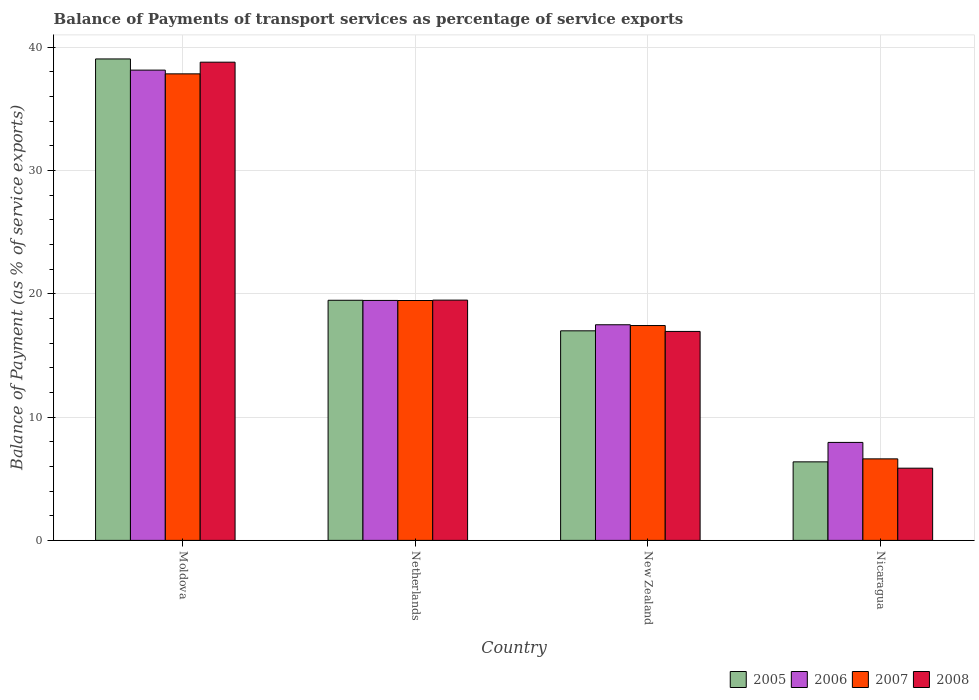How many different coloured bars are there?
Give a very brief answer. 4. Are the number of bars per tick equal to the number of legend labels?
Your response must be concise. Yes. Are the number of bars on each tick of the X-axis equal?
Provide a succinct answer. Yes. How many bars are there on the 2nd tick from the left?
Give a very brief answer. 4. What is the label of the 1st group of bars from the left?
Keep it short and to the point. Moldova. In how many cases, is the number of bars for a given country not equal to the number of legend labels?
Offer a very short reply. 0. What is the balance of payments of transport services in 2006 in Netherlands?
Offer a terse response. 19.46. Across all countries, what is the maximum balance of payments of transport services in 2008?
Your answer should be compact. 38.78. Across all countries, what is the minimum balance of payments of transport services in 2007?
Give a very brief answer. 6.61. In which country was the balance of payments of transport services in 2008 maximum?
Ensure brevity in your answer.  Moldova. In which country was the balance of payments of transport services in 2005 minimum?
Make the answer very short. Nicaragua. What is the total balance of payments of transport services in 2005 in the graph?
Offer a very short reply. 81.87. What is the difference between the balance of payments of transport services in 2006 in Netherlands and that in Nicaragua?
Offer a terse response. 11.51. What is the difference between the balance of payments of transport services in 2006 in New Zealand and the balance of payments of transport services in 2008 in Nicaragua?
Ensure brevity in your answer.  11.63. What is the average balance of payments of transport services in 2007 per country?
Your answer should be compact. 20.33. What is the difference between the balance of payments of transport services of/in 2007 and balance of payments of transport services of/in 2005 in Netherlands?
Give a very brief answer. -0.02. What is the ratio of the balance of payments of transport services in 2007 in New Zealand to that in Nicaragua?
Offer a terse response. 2.64. Is the difference between the balance of payments of transport services in 2007 in Moldova and Nicaragua greater than the difference between the balance of payments of transport services in 2005 in Moldova and Nicaragua?
Your response must be concise. No. What is the difference between the highest and the second highest balance of payments of transport services in 2007?
Offer a very short reply. -2.03. What is the difference between the highest and the lowest balance of payments of transport services in 2005?
Ensure brevity in your answer.  32.67. Is the sum of the balance of payments of transport services in 2008 in Netherlands and Nicaragua greater than the maximum balance of payments of transport services in 2007 across all countries?
Your answer should be very brief. No. What does the 3rd bar from the left in Nicaragua represents?
Offer a terse response. 2007. How many bars are there?
Keep it short and to the point. 16. How many countries are there in the graph?
Offer a terse response. 4. Are the values on the major ticks of Y-axis written in scientific E-notation?
Give a very brief answer. No. Does the graph contain grids?
Ensure brevity in your answer.  Yes. How many legend labels are there?
Your answer should be compact. 4. How are the legend labels stacked?
Ensure brevity in your answer.  Horizontal. What is the title of the graph?
Provide a succinct answer. Balance of Payments of transport services as percentage of service exports. Does "2014" appear as one of the legend labels in the graph?
Your answer should be compact. No. What is the label or title of the X-axis?
Your answer should be very brief. Country. What is the label or title of the Y-axis?
Keep it short and to the point. Balance of Payment (as % of service exports). What is the Balance of Payment (as % of service exports) in 2005 in Moldova?
Your answer should be compact. 39.04. What is the Balance of Payment (as % of service exports) in 2006 in Moldova?
Provide a short and direct response. 38.13. What is the Balance of Payment (as % of service exports) in 2007 in Moldova?
Ensure brevity in your answer.  37.83. What is the Balance of Payment (as % of service exports) of 2008 in Moldova?
Give a very brief answer. 38.78. What is the Balance of Payment (as % of service exports) of 2005 in Netherlands?
Provide a short and direct response. 19.47. What is the Balance of Payment (as % of service exports) in 2006 in Netherlands?
Provide a short and direct response. 19.46. What is the Balance of Payment (as % of service exports) of 2007 in Netherlands?
Make the answer very short. 19.45. What is the Balance of Payment (as % of service exports) in 2008 in Netherlands?
Provide a succinct answer. 19.48. What is the Balance of Payment (as % of service exports) in 2005 in New Zealand?
Make the answer very short. 16.99. What is the Balance of Payment (as % of service exports) in 2006 in New Zealand?
Provide a short and direct response. 17.48. What is the Balance of Payment (as % of service exports) in 2007 in New Zealand?
Your answer should be compact. 17.42. What is the Balance of Payment (as % of service exports) of 2008 in New Zealand?
Your answer should be compact. 16.94. What is the Balance of Payment (as % of service exports) of 2005 in Nicaragua?
Keep it short and to the point. 6.37. What is the Balance of Payment (as % of service exports) in 2006 in Nicaragua?
Your response must be concise. 7.95. What is the Balance of Payment (as % of service exports) in 2007 in Nicaragua?
Ensure brevity in your answer.  6.61. What is the Balance of Payment (as % of service exports) in 2008 in Nicaragua?
Provide a short and direct response. 5.85. Across all countries, what is the maximum Balance of Payment (as % of service exports) in 2005?
Keep it short and to the point. 39.04. Across all countries, what is the maximum Balance of Payment (as % of service exports) of 2006?
Your response must be concise. 38.13. Across all countries, what is the maximum Balance of Payment (as % of service exports) of 2007?
Your answer should be compact. 37.83. Across all countries, what is the maximum Balance of Payment (as % of service exports) in 2008?
Provide a succinct answer. 38.78. Across all countries, what is the minimum Balance of Payment (as % of service exports) in 2005?
Offer a terse response. 6.37. Across all countries, what is the minimum Balance of Payment (as % of service exports) in 2006?
Give a very brief answer. 7.95. Across all countries, what is the minimum Balance of Payment (as % of service exports) in 2007?
Offer a terse response. 6.61. Across all countries, what is the minimum Balance of Payment (as % of service exports) in 2008?
Your answer should be compact. 5.85. What is the total Balance of Payment (as % of service exports) in 2005 in the graph?
Your answer should be compact. 81.87. What is the total Balance of Payment (as % of service exports) of 2006 in the graph?
Ensure brevity in your answer.  83.02. What is the total Balance of Payment (as % of service exports) of 2007 in the graph?
Your answer should be compact. 81.31. What is the total Balance of Payment (as % of service exports) of 2008 in the graph?
Ensure brevity in your answer.  81.06. What is the difference between the Balance of Payment (as % of service exports) of 2005 in Moldova and that in Netherlands?
Provide a succinct answer. 19.57. What is the difference between the Balance of Payment (as % of service exports) of 2006 in Moldova and that in Netherlands?
Provide a short and direct response. 18.67. What is the difference between the Balance of Payment (as % of service exports) of 2007 in Moldova and that in Netherlands?
Give a very brief answer. 18.38. What is the difference between the Balance of Payment (as % of service exports) of 2008 in Moldova and that in Netherlands?
Your answer should be very brief. 19.29. What is the difference between the Balance of Payment (as % of service exports) in 2005 in Moldova and that in New Zealand?
Your answer should be very brief. 22.05. What is the difference between the Balance of Payment (as % of service exports) in 2006 in Moldova and that in New Zealand?
Offer a terse response. 20.65. What is the difference between the Balance of Payment (as % of service exports) of 2007 in Moldova and that in New Zealand?
Keep it short and to the point. 20.41. What is the difference between the Balance of Payment (as % of service exports) of 2008 in Moldova and that in New Zealand?
Provide a succinct answer. 21.83. What is the difference between the Balance of Payment (as % of service exports) in 2005 in Moldova and that in Nicaragua?
Offer a very short reply. 32.67. What is the difference between the Balance of Payment (as % of service exports) in 2006 in Moldova and that in Nicaragua?
Offer a very short reply. 30.19. What is the difference between the Balance of Payment (as % of service exports) in 2007 in Moldova and that in Nicaragua?
Your response must be concise. 31.22. What is the difference between the Balance of Payment (as % of service exports) in 2008 in Moldova and that in Nicaragua?
Offer a very short reply. 32.92. What is the difference between the Balance of Payment (as % of service exports) in 2005 in Netherlands and that in New Zealand?
Ensure brevity in your answer.  2.48. What is the difference between the Balance of Payment (as % of service exports) in 2006 in Netherlands and that in New Zealand?
Your response must be concise. 1.97. What is the difference between the Balance of Payment (as % of service exports) of 2007 in Netherlands and that in New Zealand?
Your answer should be very brief. 2.03. What is the difference between the Balance of Payment (as % of service exports) in 2008 in Netherlands and that in New Zealand?
Make the answer very short. 2.54. What is the difference between the Balance of Payment (as % of service exports) of 2005 in Netherlands and that in Nicaragua?
Provide a succinct answer. 13.1. What is the difference between the Balance of Payment (as % of service exports) of 2006 in Netherlands and that in Nicaragua?
Make the answer very short. 11.51. What is the difference between the Balance of Payment (as % of service exports) of 2007 in Netherlands and that in Nicaragua?
Offer a very short reply. 12.84. What is the difference between the Balance of Payment (as % of service exports) of 2008 in Netherlands and that in Nicaragua?
Offer a very short reply. 13.63. What is the difference between the Balance of Payment (as % of service exports) of 2005 in New Zealand and that in Nicaragua?
Offer a terse response. 10.62. What is the difference between the Balance of Payment (as % of service exports) in 2006 in New Zealand and that in Nicaragua?
Provide a short and direct response. 9.54. What is the difference between the Balance of Payment (as % of service exports) in 2007 in New Zealand and that in Nicaragua?
Offer a very short reply. 10.81. What is the difference between the Balance of Payment (as % of service exports) in 2008 in New Zealand and that in Nicaragua?
Make the answer very short. 11.09. What is the difference between the Balance of Payment (as % of service exports) of 2005 in Moldova and the Balance of Payment (as % of service exports) of 2006 in Netherlands?
Keep it short and to the point. 19.58. What is the difference between the Balance of Payment (as % of service exports) in 2005 in Moldova and the Balance of Payment (as % of service exports) in 2007 in Netherlands?
Your answer should be compact. 19.59. What is the difference between the Balance of Payment (as % of service exports) of 2005 in Moldova and the Balance of Payment (as % of service exports) of 2008 in Netherlands?
Your answer should be very brief. 19.56. What is the difference between the Balance of Payment (as % of service exports) in 2006 in Moldova and the Balance of Payment (as % of service exports) in 2007 in Netherlands?
Offer a very short reply. 18.68. What is the difference between the Balance of Payment (as % of service exports) in 2006 in Moldova and the Balance of Payment (as % of service exports) in 2008 in Netherlands?
Your answer should be very brief. 18.65. What is the difference between the Balance of Payment (as % of service exports) in 2007 in Moldova and the Balance of Payment (as % of service exports) in 2008 in Netherlands?
Make the answer very short. 18.35. What is the difference between the Balance of Payment (as % of service exports) in 2005 in Moldova and the Balance of Payment (as % of service exports) in 2006 in New Zealand?
Offer a very short reply. 21.55. What is the difference between the Balance of Payment (as % of service exports) of 2005 in Moldova and the Balance of Payment (as % of service exports) of 2007 in New Zealand?
Provide a succinct answer. 21.62. What is the difference between the Balance of Payment (as % of service exports) of 2005 in Moldova and the Balance of Payment (as % of service exports) of 2008 in New Zealand?
Offer a terse response. 22.09. What is the difference between the Balance of Payment (as % of service exports) in 2006 in Moldova and the Balance of Payment (as % of service exports) in 2007 in New Zealand?
Keep it short and to the point. 20.71. What is the difference between the Balance of Payment (as % of service exports) in 2006 in Moldova and the Balance of Payment (as % of service exports) in 2008 in New Zealand?
Provide a succinct answer. 21.19. What is the difference between the Balance of Payment (as % of service exports) of 2007 in Moldova and the Balance of Payment (as % of service exports) of 2008 in New Zealand?
Your response must be concise. 20.89. What is the difference between the Balance of Payment (as % of service exports) in 2005 in Moldova and the Balance of Payment (as % of service exports) in 2006 in Nicaragua?
Your answer should be compact. 31.09. What is the difference between the Balance of Payment (as % of service exports) in 2005 in Moldova and the Balance of Payment (as % of service exports) in 2007 in Nicaragua?
Your answer should be very brief. 32.43. What is the difference between the Balance of Payment (as % of service exports) of 2005 in Moldova and the Balance of Payment (as % of service exports) of 2008 in Nicaragua?
Make the answer very short. 33.18. What is the difference between the Balance of Payment (as % of service exports) in 2006 in Moldova and the Balance of Payment (as % of service exports) in 2007 in Nicaragua?
Make the answer very short. 31.52. What is the difference between the Balance of Payment (as % of service exports) in 2006 in Moldova and the Balance of Payment (as % of service exports) in 2008 in Nicaragua?
Offer a very short reply. 32.28. What is the difference between the Balance of Payment (as % of service exports) in 2007 in Moldova and the Balance of Payment (as % of service exports) in 2008 in Nicaragua?
Keep it short and to the point. 31.98. What is the difference between the Balance of Payment (as % of service exports) of 2005 in Netherlands and the Balance of Payment (as % of service exports) of 2006 in New Zealand?
Keep it short and to the point. 1.99. What is the difference between the Balance of Payment (as % of service exports) of 2005 in Netherlands and the Balance of Payment (as % of service exports) of 2007 in New Zealand?
Provide a succinct answer. 2.05. What is the difference between the Balance of Payment (as % of service exports) of 2005 in Netherlands and the Balance of Payment (as % of service exports) of 2008 in New Zealand?
Offer a terse response. 2.53. What is the difference between the Balance of Payment (as % of service exports) in 2006 in Netherlands and the Balance of Payment (as % of service exports) in 2007 in New Zealand?
Provide a short and direct response. 2.04. What is the difference between the Balance of Payment (as % of service exports) in 2006 in Netherlands and the Balance of Payment (as % of service exports) in 2008 in New Zealand?
Your answer should be very brief. 2.51. What is the difference between the Balance of Payment (as % of service exports) of 2007 in Netherlands and the Balance of Payment (as % of service exports) of 2008 in New Zealand?
Your response must be concise. 2.51. What is the difference between the Balance of Payment (as % of service exports) of 2005 in Netherlands and the Balance of Payment (as % of service exports) of 2006 in Nicaragua?
Your response must be concise. 11.52. What is the difference between the Balance of Payment (as % of service exports) of 2005 in Netherlands and the Balance of Payment (as % of service exports) of 2007 in Nicaragua?
Your answer should be very brief. 12.86. What is the difference between the Balance of Payment (as % of service exports) in 2005 in Netherlands and the Balance of Payment (as % of service exports) in 2008 in Nicaragua?
Provide a short and direct response. 13.62. What is the difference between the Balance of Payment (as % of service exports) in 2006 in Netherlands and the Balance of Payment (as % of service exports) in 2007 in Nicaragua?
Offer a very short reply. 12.85. What is the difference between the Balance of Payment (as % of service exports) in 2006 in Netherlands and the Balance of Payment (as % of service exports) in 2008 in Nicaragua?
Provide a short and direct response. 13.6. What is the difference between the Balance of Payment (as % of service exports) of 2007 in Netherlands and the Balance of Payment (as % of service exports) of 2008 in Nicaragua?
Keep it short and to the point. 13.6. What is the difference between the Balance of Payment (as % of service exports) in 2005 in New Zealand and the Balance of Payment (as % of service exports) in 2006 in Nicaragua?
Your response must be concise. 9.05. What is the difference between the Balance of Payment (as % of service exports) in 2005 in New Zealand and the Balance of Payment (as % of service exports) in 2007 in Nicaragua?
Your answer should be very brief. 10.38. What is the difference between the Balance of Payment (as % of service exports) of 2005 in New Zealand and the Balance of Payment (as % of service exports) of 2008 in Nicaragua?
Your response must be concise. 11.14. What is the difference between the Balance of Payment (as % of service exports) of 2006 in New Zealand and the Balance of Payment (as % of service exports) of 2007 in Nicaragua?
Your answer should be compact. 10.87. What is the difference between the Balance of Payment (as % of service exports) of 2006 in New Zealand and the Balance of Payment (as % of service exports) of 2008 in Nicaragua?
Your answer should be very brief. 11.63. What is the difference between the Balance of Payment (as % of service exports) in 2007 in New Zealand and the Balance of Payment (as % of service exports) in 2008 in Nicaragua?
Give a very brief answer. 11.57. What is the average Balance of Payment (as % of service exports) of 2005 per country?
Provide a short and direct response. 20.47. What is the average Balance of Payment (as % of service exports) in 2006 per country?
Give a very brief answer. 20.76. What is the average Balance of Payment (as % of service exports) in 2007 per country?
Ensure brevity in your answer.  20.33. What is the average Balance of Payment (as % of service exports) of 2008 per country?
Your answer should be compact. 20.26. What is the difference between the Balance of Payment (as % of service exports) in 2005 and Balance of Payment (as % of service exports) in 2006 in Moldova?
Make the answer very short. 0.91. What is the difference between the Balance of Payment (as % of service exports) in 2005 and Balance of Payment (as % of service exports) in 2007 in Moldova?
Provide a short and direct response. 1.21. What is the difference between the Balance of Payment (as % of service exports) in 2005 and Balance of Payment (as % of service exports) in 2008 in Moldova?
Give a very brief answer. 0.26. What is the difference between the Balance of Payment (as % of service exports) in 2006 and Balance of Payment (as % of service exports) in 2007 in Moldova?
Your answer should be compact. 0.3. What is the difference between the Balance of Payment (as % of service exports) of 2006 and Balance of Payment (as % of service exports) of 2008 in Moldova?
Keep it short and to the point. -0.64. What is the difference between the Balance of Payment (as % of service exports) in 2007 and Balance of Payment (as % of service exports) in 2008 in Moldova?
Give a very brief answer. -0.95. What is the difference between the Balance of Payment (as % of service exports) in 2005 and Balance of Payment (as % of service exports) in 2006 in Netherlands?
Make the answer very short. 0.01. What is the difference between the Balance of Payment (as % of service exports) of 2005 and Balance of Payment (as % of service exports) of 2007 in Netherlands?
Make the answer very short. 0.02. What is the difference between the Balance of Payment (as % of service exports) in 2005 and Balance of Payment (as % of service exports) in 2008 in Netherlands?
Provide a succinct answer. -0.01. What is the difference between the Balance of Payment (as % of service exports) of 2006 and Balance of Payment (as % of service exports) of 2007 in Netherlands?
Provide a short and direct response. 0.01. What is the difference between the Balance of Payment (as % of service exports) of 2006 and Balance of Payment (as % of service exports) of 2008 in Netherlands?
Offer a terse response. -0.03. What is the difference between the Balance of Payment (as % of service exports) in 2007 and Balance of Payment (as % of service exports) in 2008 in Netherlands?
Offer a terse response. -0.03. What is the difference between the Balance of Payment (as % of service exports) in 2005 and Balance of Payment (as % of service exports) in 2006 in New Zealand?
Offer a terse response. -0.49. What is the difference between the Balance of Payment (as % of service exports) of 2005 and Balance of Payment (as % of service exports) of 2007 in New Zealand?
Ensure brevity in your answer.  -0.43. What is the difference between the Balance of Payment (as % of service exports) of 2005 and Balance of Payment (as % of service exports) of 2008 in New Zealand?
Ensure brevity in your answer.  0.05. What is the difference between the Balance of Payment (as % of service exports) in 2006 and Balance of Payment (as % of service exports) in 2007 in New Zealand?
Your response must be concise. 0.06. What is the difference between the Balance of Payment (as % of service exports) of 2006 and Balance of Payment (as % of service exports) of 2008 in New Zealand?
Your response must be concise. 0.54. What is the difference between the Balance of Payment (as % of service exports) of 2007 and Balance of Payment (as % of service exports) of 2008 in New Zealand?
Offer a terse response. 0.48. What is the difference between the Balance of Payment (as % of service exports) of 2005 and Balance of Payment (as % of service exports) of 2006 in Nicaragua?
Keep it short and to the point. -1.58. What is the difference between the Balance of Payment (as % of service exports) in 2005 and Balance of Payment (as % of service exports) in 2007 in Nicaragua?
Give a very brief answer. -0.24. What is the difference between the Balance of Payment (as % of service exports) of 2005 and Balance of Payment (as % of service exports) of 2008 in Nicaragua?
Make the answer very short. 0.51. What is the difference between the Balance of Payment (as % of service exports) in 2006 and Balance of Payment (as % of service exports) in 2007 in Nicaragua?
Keep it short and to the point. 1.33. What is the difference between the Balance of Payment (as % of service exports) in 2006 and Balance of Payment (as % of service exports) in 2008 in Nicaragua?
Offer a very short reply. 2.09. What is the difference between the Balance of Payment (as % of service exports) in 2007 and Balance of Payment (as % of service exports) in 2008 in Nicaragua?
Offer a terse response. 0.76. What is the ratio of the Balance of Payment (as % of service exports) of 2005 in Moldova to that in Netherlands?
Offer a terse response. 2.01. What is the ratio of the Balance of Payment (as % of service exports) in 2006 in Moldova to that in Netherlands?
Ensure brevity in your answer.  1.96. What is the ratio of the Balance of Payment (as % of service exports) of 2007 in Moldova to that in Netherlands?
Keep it short and to the point. 1.94. What is the ratio of the Balance of Payment (as % of service exports) of 2008 in Moldova to that in Netherlands?
Offer a terse response. 1.99. What is the ratio of the Balance of Payment (as % of service exports) in 2005 in Moldova to that in New Zealand?
Provide a succinct answer. 2.3. What is the ratio of the Balance of Payment (as % of service exports) of 2006 in Moldova to that in New Zealand?
Keep it short and to the point. 2.18. What is the ratio of the Balance of Payment (as % of service exports) in 2007 in Moldova to that in New Zealand?
Your response must be concise. 2.17. What is the ratio of the Balance of Payment (as % of service exports) of 2008 in Moldova to that in New Zealand?
Offer a terse response. 2.29. What is the ratio of the Balance of Payment (as % of service exports) of 2005 in Moldova to that in Nicaragua?
Give a very brief answer. 6.13. What is the ratio of the Balance of Payment (as % of service exports) in 2006 in Moldova to that in Nicaragua?
Provide a succinct answer. 4.8. What is the ratio of the Balance of Payment (as % of service exports) of 2007 in Moldova to that in Nicaragua?
Make the answer very short. 5.72. What is the ratio of the Balance of Payment (as % of service exports) in 2008 in Moldova to that in Nicaragua?
Offer a very short reply. 6.62. What is the ratio of the Balance of Payment (as % of service exports) in 2005 in Netherlands to that in New Zealand?
Ensure brevity in your answer.  1.15. What is the ratio of the Balance of Payment (as % of service exports) of 2006 in Netherlands to that in New Zealand?
Ensure brevity in your answer.  1.11. What is the ratio of the Balance of Payment (as % of service exports) of 2007 in Netherlands to that in New Zealand?
Offer a very short reply. 1.12. What is the ratio of the Balance of Payment (as % of service exports) of 2008 in Netherlands to that in New Zealand?
Ensure brevity in your answer.  1.15. What is the ratio of the Balance of Payment (as % of service exports) in 2005 in Netherlands to that in Nicaragua?
Keep it short and to the point. 3.06. What is the ratio of the Balance of Payment (as % of service exports) of 2006 in Netherlands to that in Nicaragua?
Your response must be concise. 2.45. What is the ratio of the Balance of Payment (as % of service exports) in 2007 in Netherlands to that in Nicaragua?
Your answer should be compact. 2.94. What is the ratio of the Balance of Payment (as % of service exports) of 2008 in Netherlands to that in Nicaragua?
Your response must be concise. 3.33. What is the ratio of the Balance of Payment (as % of service exports) in 2005 in New Zealand to that in Nicaragua?
Offer a very short reply. 2.67. What is the ratio of the Balance of Payment (as % of service exports) of 2006 in New Zealand to that in Nicaragua?
Offer a terse response. 2.2. What is the ratio of the Balance of Payment (as % of service exports) of 2007 in New Zealand to that in Nicaragua?
Ensure brevity in your answer.  2.64. What is the ratio of the Balance of Payment (as % of service exports) in 2008 in New Zealand to that in Nicaragua?
Keep it short and to the point. 2.89. What is the difference between the highest and the second highest Balance of Payment (as % of service exports) of 2005?
Your answer should be very brief. 19.57. What is the difference between the highest and the second highest Balance of Payment (as % of service exports) of 2006?
Your answer should be compact. 18.67. What is the difference between the highest and the second highest Balance of Payment (as % of service exports) of 2007?
Offer a terse response. 18.38. What is the difference between the highest and the second highest Balance of Payment (as % of service exports) of 2008?
Make the answer very short. 19.29. What is the difference between the highest and the lowest Balance of Payment (as % of service exports) in 2005?
Your answer should be compact. 32.67. What is the difference between the highest and the lowest Balance of Payment (as % of service exports) in 2006?
Provide a succinct answer. 30.19. What is the difference between the highest and the lowest Balance of Payment (as % of service exports) in 2007?
Give a very brief answer. 31.22. What is the difference between the highest and the lowest Balance of Payment (as % of service exports) in 2008?
Keep it short and to the point. 32.92. 